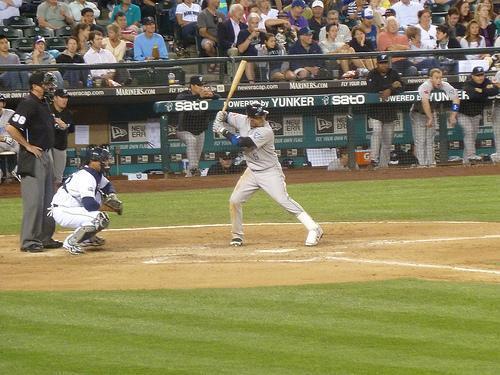How many catchers are there?
Give a very brief answer. 1. 